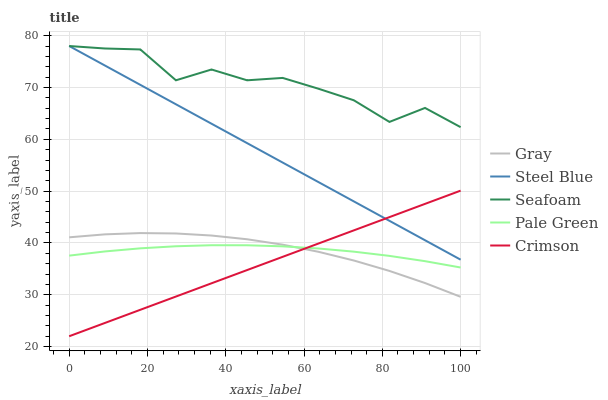Does Crimson have the minimum area under the curve?
Answer yes or no. Yes. Does Seafoam have the maximum area under the curve?
Answer yes or no. Yes. Does Gray have the minimum area under the curve?
Answer yes or no. No. Does Gray have the maximum area under the curve?
Answer yes or no. No. Is Steel Blue the smoothest?
Answer yes or no. Yes. Is Seafoam the roughest?
Answer yes or no. Yes. Is Gray the smoothest?
Answer yes or no. No. Is Gray the roughest?
Answer yes or no. No. Does Crimson have the lowest value?
Answer yes or no. Yes. Does Gray have the lowest value?
Answer yes or no. No. Does Seafoam have the highest value?
Answer yes or no. Yes. Does Gray have the highest value?
Answer yes or no. No. Is Pale Green less than Seafoam?
Answer yes or no. Yes. Is Steel Blue greater than Gray?
Answer yes or no. Yes. Does Seafoam intersect Steel Blue?
Answer yes or no. Yes. Is Seafoam less than Steel Blue?
Answer yes or no. No. Is Seafoam greater than Steel Blue?
Answer yes or no. No. Does Pale Green intersect Seafoam?
Answer yes or no. No. 